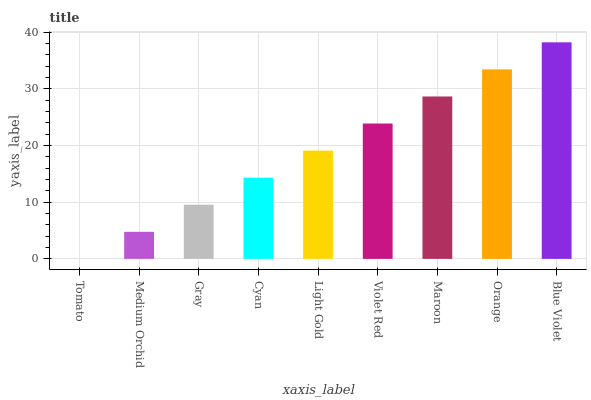Is Tomato the minimum?
Answer yes or no. Yes. Is Blue Violet the maximum?
Answer yes or no. Yes. Is Medium Orchid the minimum?
Answer yes or no. No. Is Medium Orchid the maximum?
Answer yes or no. No. Is Medium Orchid greater than Tomato?
Answer yes or no. Yes. Is Tomato less than Medium Orchid?
Answer yes or no. Yes. Is Tomato greater than Medium Orchid?
Answer yes or no. No. Is Medium Orchid less than Tomato?
Answer yes or no. No. Is Light Gold the high median?
Answer yes or no. Yes. Is Light Gold the low median?
Answer yes or no. Yes. Is Gray the high median?
Answer yes or no. No. Is Maroon the low median?
Answer yes or no. No. 